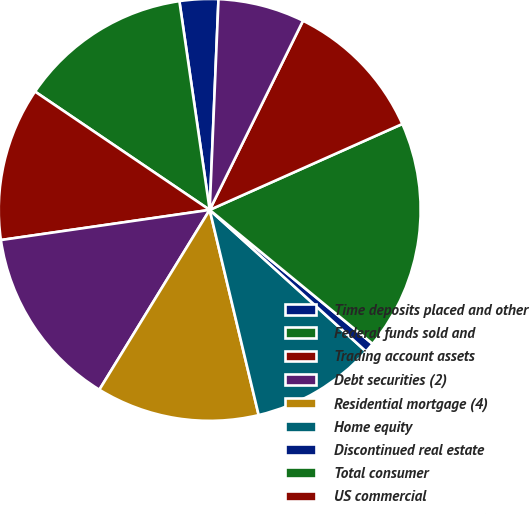<chart> <loc_0><loc_0><loc_500><loc_500><pie_chart><fcel>Time deposits placed and other<fcel>Federal funds sold and<fcel>Trading account assets<fcel>Debt securities (2)<fcel>Residential mortgage (4)<fcel>Home equity<fcel>Discontinued real estate<fcel>Total consumer<fcel>US commercial<fcel>Commercial real estate (7)<nl><fcel>2.96%<fcel>13.23%<fcel>11.76%<fcel>13.96%<fcel>12.49%<fcel>9.56%<fcel>0.76%<fcel>17.63%<fcel>11.03%<fcel>6.63%<nl></chart> 